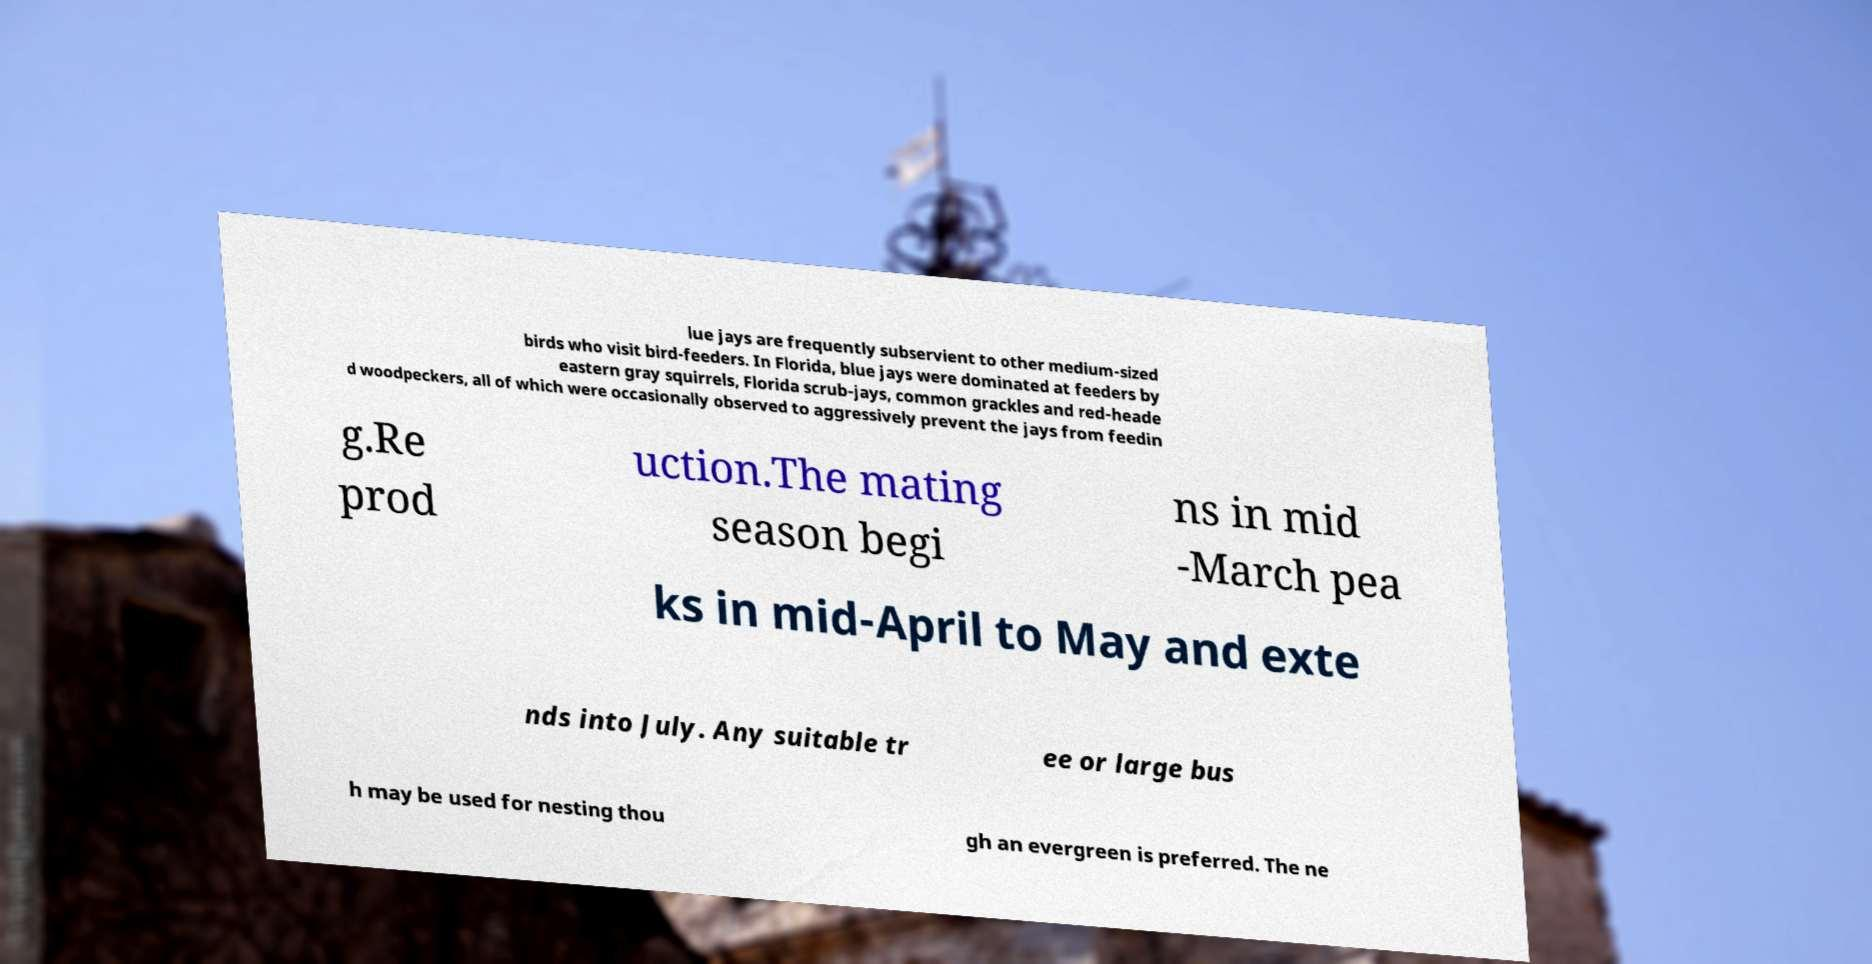There's text embedded in this image that I need extracted. Can you transcribe it verbatim? lue jays are frequently subservient to other medium-sized birds who visit bird-feeders. In Florida, blue jays were dominated at feeders by eastern gray squirrels, Florida scrub-jays, common grackles and red-heade d woodpeckers, all of which were occasionally observed to aggressively prevent the jays from feedin g.Re prod uction.The mating season begi ns in mid -March pea ks in mid-April to May and exte nds into July. Any suitable tr ee or large bus h may be used for nesting thou gh an evergreen is preferred. The ne 